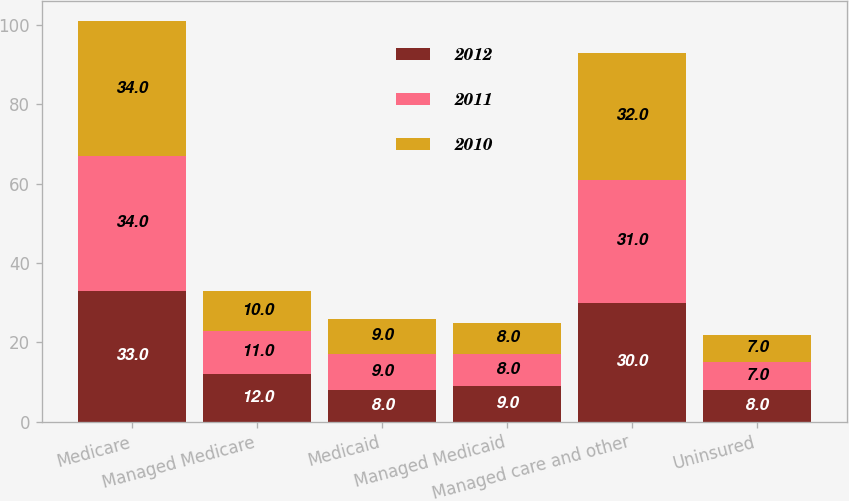Convert chart to OTSL. <chart><loc_0><loc_0><loc_500><loc_500><stacked_bar_chart><ecel><fcel>Medicare<fcel>Managed Medicare<fcel>Medicaid<fcel>Managed Medicaid<fcel>Managed care and other<fcel>Uninsured<nl><fcel>2012<fcel>33<fcel>12<fcel>8<fcel>9<fcel>30<fcel>8<nl><fcel>2011<fcel>34<fcel>11<fcel>9<fcel>8<fcel>31<fcel>7<nl><fcel>2010<fcel>34<fcel>10<fcel>9<fcel>8<fcel>32<fcel>7<nl></chart> 